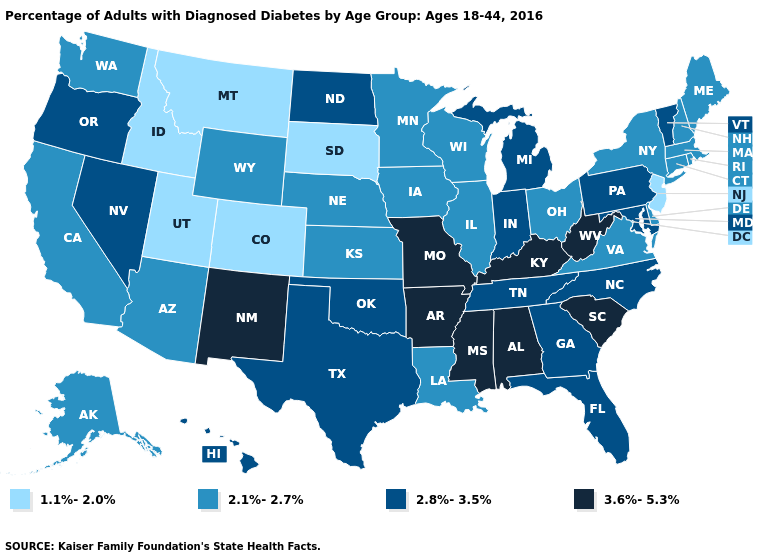What is the lowest value in states that border Delaware?
Concise answer only. 1.1%-2.0%. Name the states that have a value in the range 1.1%-2.0%?
Concise answer only. Colorado, Idaho, Montana, New Jersey, South Dakota, Utah. What is the highest value in the USA?
Be succinct. 3.6%-5.3%. What is the value of New York?
Answer briefly. 2.1%-2.7%. Name the states that have a value in the range 2.8%-3.5%?
Keep it brief. Florida, Georgia, Hawaii, Indiana, Maryland, Michigan, Nevada, North Carolina, North Dakota, Oklahoma, Oregon, Pennsylvania, Tennessee, Texas, Vermont. Does the first symbol in the legend represent the smallest category?
Quick response, please. Yes. Name the states that have a value in the range 2.1%-2.7%?
Write a very short answer. Alaska, Arizona, California, Connecticut, Delaware, Illinois, Iowa, Kansas, Louisiana, Maine, Massachusetts, Minnesota, Nebraska, New Hampshire, New York, Ohio, Rhode Island, Virginia, Washington, Wisconsin, Wyoming. How many symbols are there in the legend?
Answer briefly. 4. Is the legend a continuous bar?
Quick response, please. No. What is the highest value in states that border Utah?
Answer briefly. 3.6%-5.3%. What is the value of Utah?
Short answer required. 1.1%-2.0%. Name the states that have a value in the range 3.6%-5.3%?
Concise answer only. Alabama, Arkansas, Kentucky, Mississippi, Missouri, New Mexico, South Carolina, West Virginia. Does South Carolina have the lowest value in the USA?
Keep it brief. No. Name the states that have a value in the range 1.1%-2.0%?
Answer briefly. Colorado, Idaho, Montana, New Jersey, South Dakota, Utah. What is the highest value in the USA?
Be succinct. 3.6%-5.3%. 